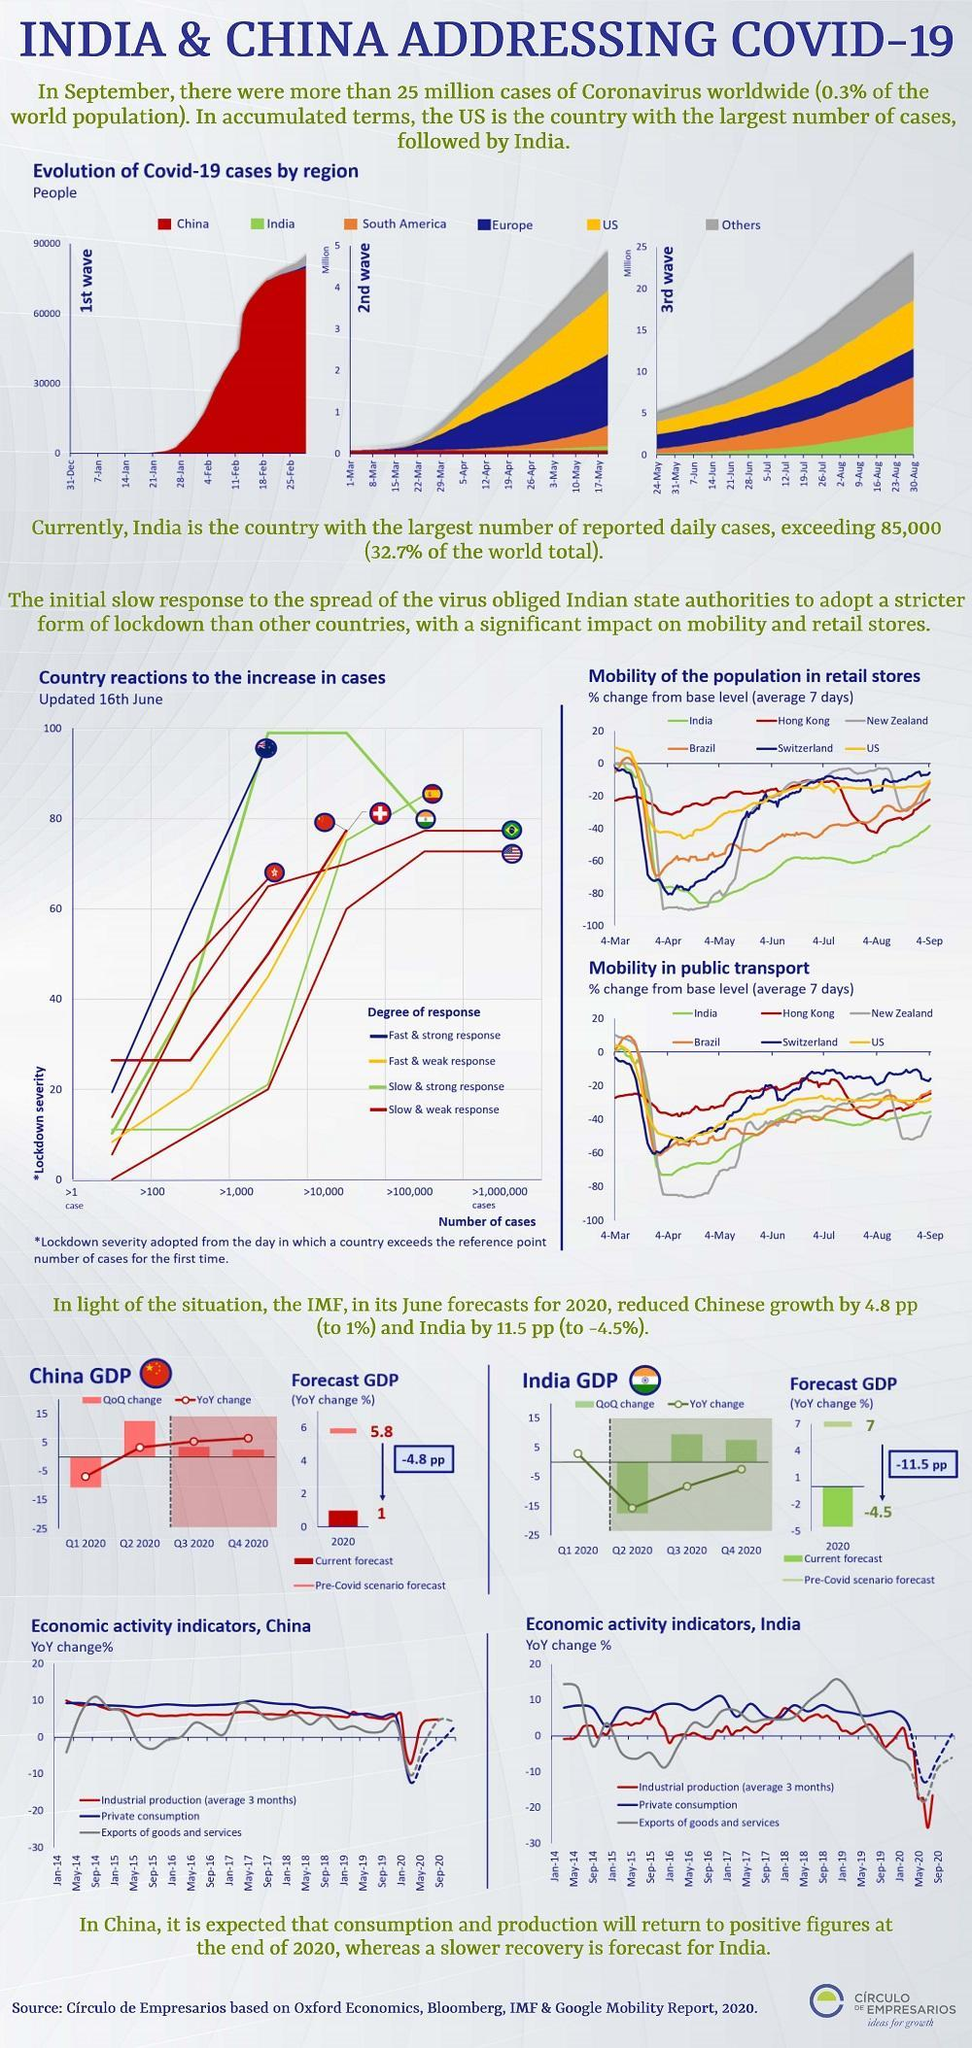Which color is used to represent china-yellow, orange, red, or blue?
Answer the question with a short phrase. red Which country has a slow and strong degree of response-America, China, Australia, or India? India Which country has a fast and strong degree of response-America, China, Australia, or India? Australia Which country has a slow and weak degree of response-America, China, Australia, or India? America 